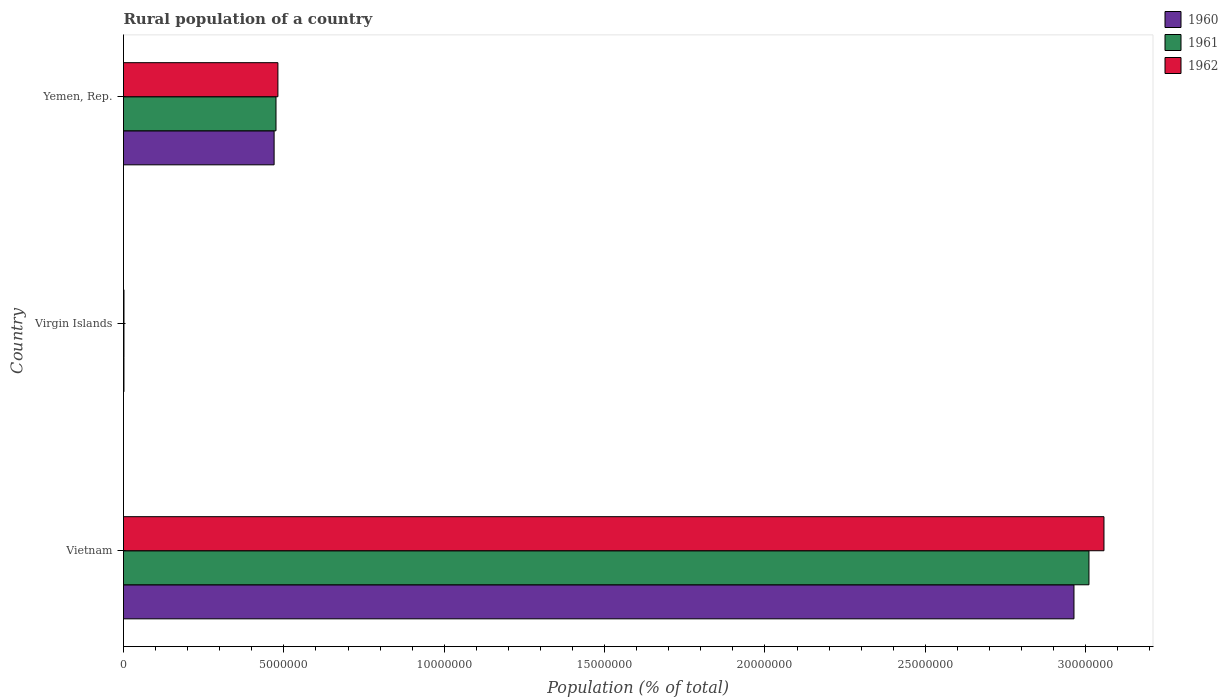How many groups of bars are there?
Offer a terse response. 3. Are the number of bars on each tick of the Y-axis equal?
Ensure brevity in your answer.  Yes. How many bars are there on the 1st tick from the top?
Keep it short and to the point. 3. How many bars are there on the 3rd tick from the bottom?
Offer a terse response. 3. What is the label of the 3rd group of bars from the top?
Provide a short and direct response. Vietnam. In how many cases, is the number of bars for a given country not equal to the number of legend labels?
Your response must be concise. 0. What is the rural population in 1961 in Virgin Islands?
Offer a very short reply. 1.44e+04. Across all countries, what is the maximum rural population in 1960?
Offer a terse response. 2.96e+07. Across all countries, what is the minimum rural population in 1962?
Offer a terse response. 1.48e+04. In which country was the rural population in 1960 maximum?
Make the answer very short. Vietnam. In which country was the rural population in 1961 minimum?
Give a very brief answer. Virgin Islands. What is the total rural population in 1962 in the graph?
Give a very brief answer. 3.54e+07. What is the difference between the rural population in 1961 in Vietnam and that in Yemen, Rep.?
Your answer should be compact. 2.53e+07. What is the difference between the rural population in 1960 in Virgin Islands and the rural population in 1961 in Yemen, Rep.?
Make the answer very short. -4.74e+06. What is the average rural population in 1961 per country?
Give a very brief answer. 1.16e+07. What is the difference between the rural population in 1961 and rural population in 1962 in Yemen, Rep.?
Your answer should be very brief. -5.95e+04. What is the ratio of the rural population in 1962 in Vietnam to that in Yemen, Rep.?
Offer a very short reply. 6.35. What is the difference between the highest and the second highest rural population in 1960?
Ensure brevity in your answer.  2.49e+07. What is the difference between the highest and the lowest rural population in 1962?
Offer a very short reply. 3.06e+07. Is the sum of the rural population in 1961 in Vietnam and Yemen, Rep. greater than the maximum rural population in 1962 across all countries?
Give a very brief answer. Yes. Is it the case that in every country, the sum of the rural population in 1960 and rural population in 1961 is greater than the rural population in 1962?
Keep it short and to the point. Yes. How many countries are there in the graph?
Keep it short and to the point. 3. What is the difference between two consecutive major ticks on the X-axis?
Provide a short and direct response. 5.00e+06. Are the values on the major ticks of X-axis written in scientific E-notation?
Make the answer very short. No. Does the graph contain any zero values?
Offer a very short reply. No. Does the graph contain grids?
Make the answer very short. No. Where does the legend appear in the graph?
Your answer should be very brief. Top right. What is the title of the graph?
Keep it short and to the point. Rural population of a country. What is the label or title of the X-axis?
Offer a very short reply. Population (% of total). What is the label or title of the Y-axis?
Offer a terse response. Country. What is the Population (% of total) in 1960 in Vietnam?
Give a very brief answer. 2.96e+07. What is the Population (% of total) of 1961 in Vietnam?
Your answer should be compact. 3.01e+07. What is the Population (% of total) in 1962 in Vietnam?
Provide a succinct answer. 3.06e+07. What is the Population (% of total) of 1960 in Virgin Islands?
Offer a very short reply. 1.39e+04. What is the Population (% of total) of 1961 in Virgin Islands?
Offer a very short reply. 1.44e+04. What is the Population (% of total) in 1962 in Virgin Islands?
Provide a short and direct response. 1.48e+04. What is the Population (% of total) in 1960 in Yemen, Rep.?
Give a very brief answer. 4.70e+06. What is the Population (% of total) in 1961 in Yemen, Rep.?
Give a very brief answer. 4.75e+06. What is the Population (% of total) of 1962 in Yemen, Rep.?
Make the answer very short. 4.81e+06. Across all countries, what is the maximum Population (% of total) of 1960?
Provide a succinct answer. 2.96e+07. Across all countries, what is the maximum Population (% of total) in 1961?
Offer a terse response. 3.01e+07. Across all countries, what is the maximum Population (% of total) in 1962?
Keep it short and to the point. 3.06e+07. Across all countries, what is the minimum Population (% of total) of 1960?
Provide a short and direct response. 1.39e+04. Across all countries, what is the minimum Population (% of total) in 1961?
Provide a short and direct response. 1.44e+04. Across all countries, what is the minimum Population (% of total) of 1962?
Give a very brief answer. 1.48e+04. What is the total Population (% of total) in 1960 in the graph?
Keep it short and to the point. 3.43e+07. What is the total Population (% of total) in 1961 in the graph?
Keep it short and to the point. 3.49e+07. What is the total Population (% of total) in 1962 in the graph?
Provide a short and direct response. 3.54e+07. What is the difference between the Population (% of total) in 1960 in Vietnam and that in Virgin Islands?
Offer a very short reply. 2.96e+07. What is the difference between the Population (% of total) of 1961 in Vietnam and that in Virgin Islands?
Keep it short and to the point. 3.01e+07. What is the difference between the Population (% of total) in 1962 in Vietnam and that in Virgin Islands?
Your response must be concise. 3.06e+07. What is the difference between the Population (% of total) of 1960 in Vietnam and that in Yemen, Rep.?
Your response must be concise. 2.49e+07. What is the difference between the Population (% of total) of 1961 in Vietnam and that in Yemen, Rep.?
Make the answer very short. 2.53e+07. What is the difference between the Population (% of total) in 1962 in Vietnam and that in Yemen, Rep.?
Offer a terse response. 2.58e+07. What is the difference between the Population (% of total) of 1960 in Virgin Islands and that in Yemen, Rep.?
Your answer should be compact. -4.68e+06. What is the difference between the Population (% of total) in 1961 in Virgin Islands and that in Yemen, Rep.?
Offer a terse response. -4.74e+06. What is the difference between the Population (% of total) of 1962 in Virgin Islands and that in Yemen, Rep.?
Give a very brief answer. -4.80e+06. What is the difference between the Population (% of total) of 1960 in Vietnam and the Population (% of total) of 1961 in Virgin Islands?
Ensure brevity in your answer.  2.96e+07. What is the difference between the Population (% of total) of 1960 in Vietnam and the Population (% of total) of 1962 in Virgin Islands?
Offer a terse response. 2.96e+07. What is the difference between the Population (% of total) of 1961 in Vietnam and the Population (% of total) of 1962 in Virgin Islands?
Your answer should be compact. 3.01e+07. What is the difference between the Population (% of total) in 1960 in Vietnam and the Population (% of total) in 1961 in Yemen, Rep.?
Ensure brevity in your answer.  2.49e+07. What is the difference between the Population (% of total) in 1960 in Vietnam and the Population (% of total) in 1962 in Yemen, Rep.?
Your response must be concise. 2.48e+07. What is the difference between the Population (% of total) of 1961 in Vietnam and the Population (% of total) of 1962 in Yemen, Rep.?
Your response must be concise. 2.53e+07. What is the difference between the Population (% of total) of 1960 in Virgin Islands and the Population (% of total) of 1961 in Yemen, Rep.?
Keep it short and to the point. -4.74e+06. What is the difference between the Population (% of total) of 1960 in Virgin Islands and the Population (% of total) of 1962 in Yemen, Rep.?
Provide a short and direct response. -4.80e+06. What is the difference between the Population (% of total) of 1961 in Virgin Islands and the Population (% of total) of 1962 in Yemen, Rep.?
Provide a succinct answer. -4.80e+06. What is the average Population (% of total) of 1960 per country?
Offer a terse response. 1.14e+07. What is the average Population (% of total) of 1961 per country?
Your answer should be compact. 1.16e+07. What is the average Population (% of total) of 1962 per country?
Your answer should be compact. 1.18e+07. What is the difference between the Population (% of total) in 1960 and Population (% of total) in 1961 in Vietnam?
Ensure brevity in your answer.  -4.67e+05. What is the difference between the Population (% of total) of 1960 and Population (% of total) of 1962 in Vietnam?
Offer a very short reply. -9.35e+05. What is the difference between the Population (% of total) of 1961 and Population (% of total) of 1962 in Vietnam?
Your answer should be compact. -4.68e+05. What is the difference between the Population (% of total) in 1960 and Population (% of total) in 1961 in Virgin Islands?
Your answer should be compact. -441. What is the difference between the Population (% of total) in 1960 and Population (% of total) in 1962 in Virgin Islands?
Make the answer very short. -869. What is the difference between the Population (% of total) in 1961 and Population (% of total) in 1962 in Virgin Islands?
Offer a terse response. -428. What is the difference between the Population (% of total) in 1960 and Population (% of total) in 1961 in Yemen, Rep.?
Provide a short and direct response. -5.87e+04. What is the difference between the Population (% of total) of 1960 and Population (% of total) of 1962 in Yemen, Rep.?
Give a very brief answer. -1.18e+05. What is the difference between the Population (% of total) of 1961 and Population (% of total) of 1962 in Yemen, Rep.?
Your response must be concise. -5.95e+04. What is the ratio of the Population (% of total) of 1960 in Vietnam to that in Virgin Islands?
Give a very brief answer. 2127.94. What is the ratio of the Population (% of total) of 1961 in Vietnam to that in Virgin Islands?
Your response must be concise. 2095.13. What is the ratio of the Population (% of total) in 1962 in Vietnam to that in Virgin Islands?
Your answer should be compact. 2066.18. What is the ratio of the Population (% of total) of 1960 in Vietnam to that in Yemen, Rep.?
Keep it short and to the point. 6.31. What is the ratio of the Population (% of total) of 1961 in Vietnam to that in Yemen, Rep.?
Keep it short and to the point. 6.33. What is the ratio of the Population (% of total) of 1962 in Vietnam to that in Yemen, Rep.?
Offer a very short reply. 6.35. What is the ratio of the Population (% of total) in 1960 in Virgin Islands to that in Yemen, Rep.?
Give a very brief answer. 0. What is the ratio of the Population (% of total) of 1961 in Virgin Islands to that in Yemen, Rep.?
Offer a terse response. 0. What is the ratio of the Population (% of total) of 1962 in Virgin Islands to that in Yemen, Rep.?
Provide a short and direct response. 0. What is the difference between the highest and the second highest Population (% of total) in 1960?
Offer a terse response. 2.49e+07. What is the difference between the highest and the second highest Population (% of total) of 1961?
Provide a succinct answer. 2.53e+07. What is the difference between the highest and the second highest Population (% of total) of 1962?
Offer a very short reply. 2.58e+07. What is the difference between the highest and the lowest Population (% of total) of 1960?
Your answer should be very brief. 2.96e+07. What is the difference between the highest and the lowest Population (% of total) in 1961?
Offer a terse response. 3.01e+07. What is the difference between the highest and the lowest Population (% of total) of 1962?
Offer a very short reply. 3.06e+07. 